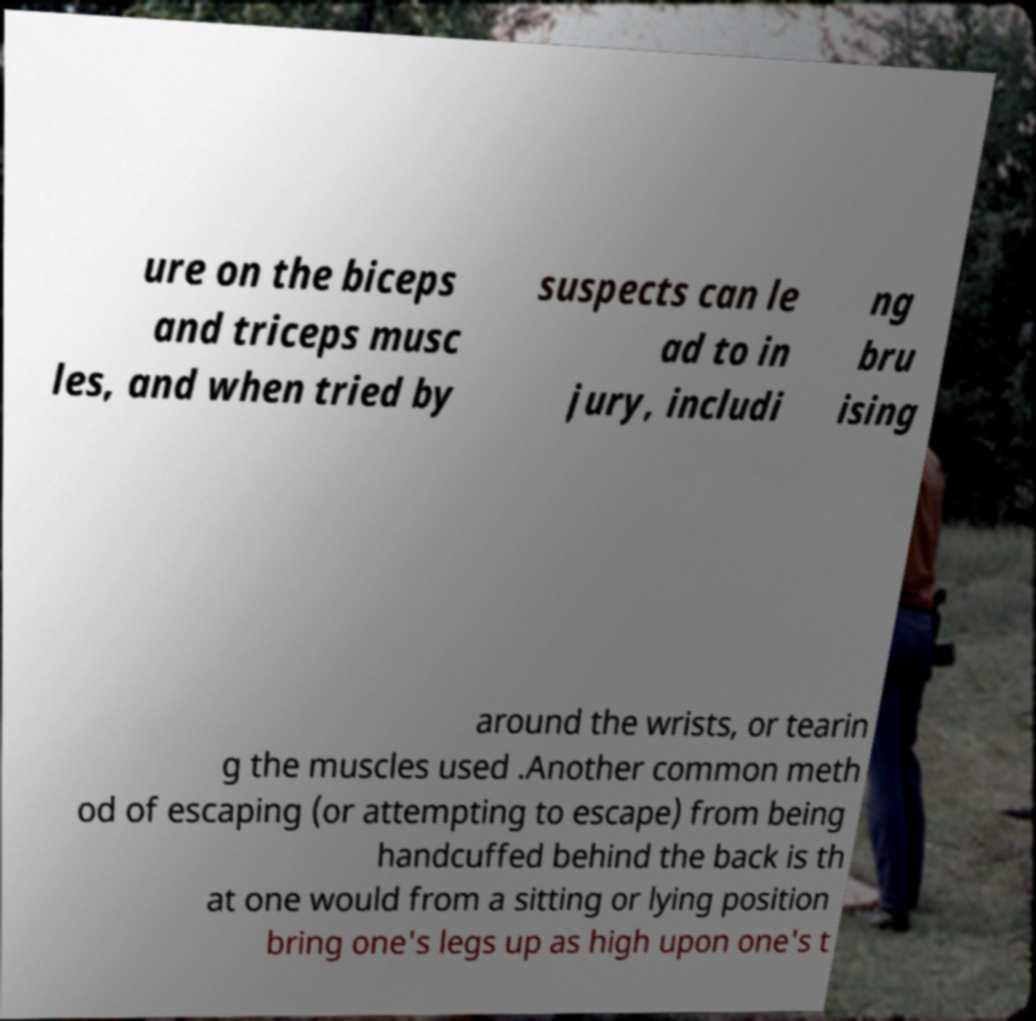Could you extract and type out the text from this image? ure on the biceps and triceps musc les, and when tried by suspects can le ad to in jury, includi ng bru ising around the wrists, or tearin g the muscles used .Another common meth od of escaping (or attempting to escape) from being handcuffed behind the back is th at one would from a sitting or lying position bring one's legs up as high upon one's t 